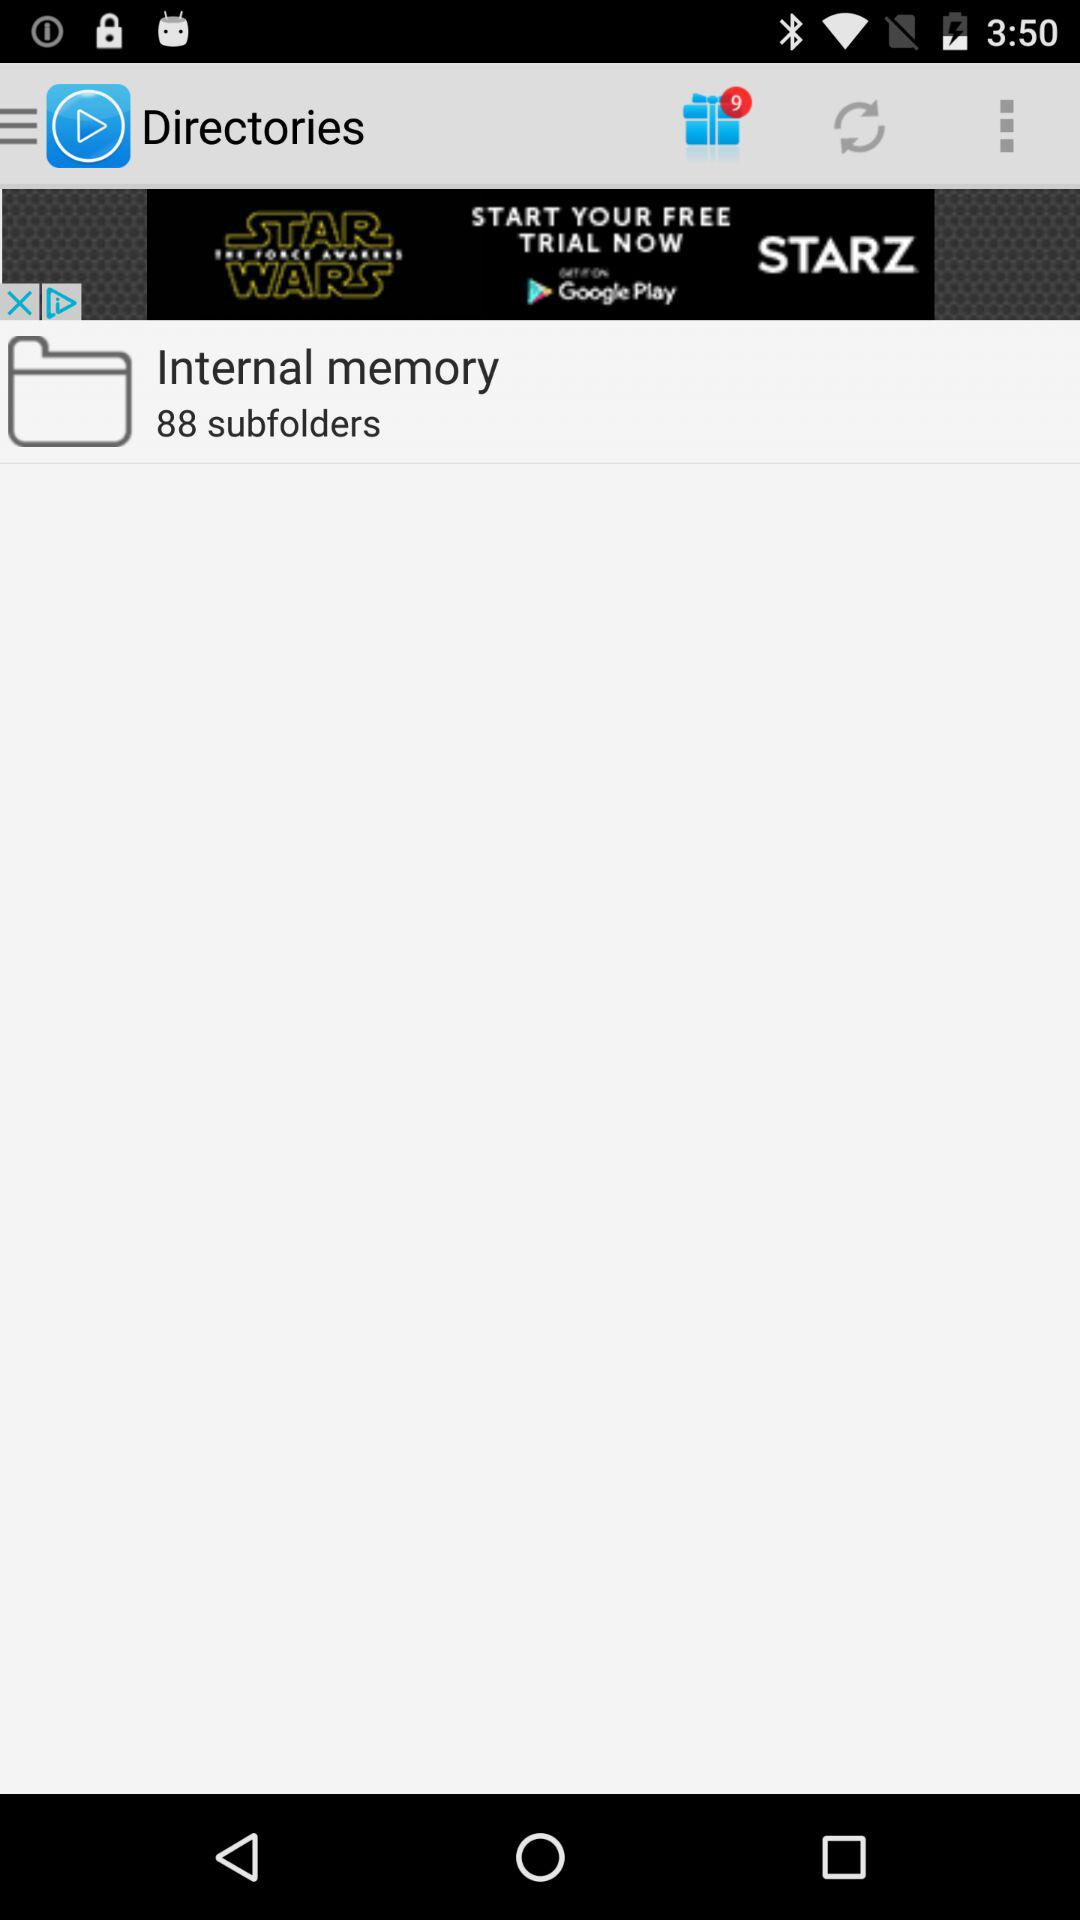How many subfolders are there in the internal memory? There are 88 subfolders in the internal memory. 